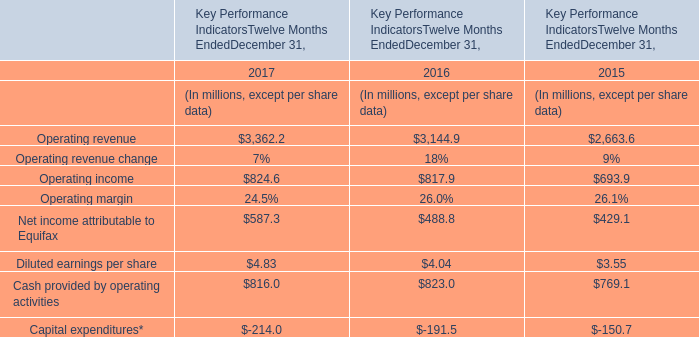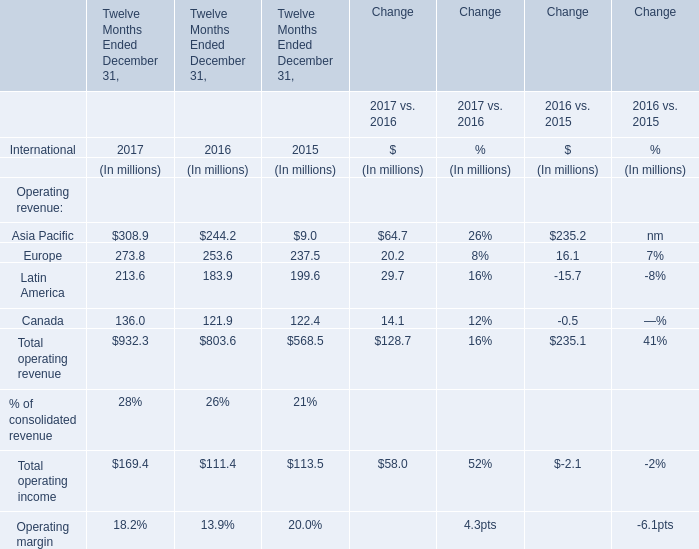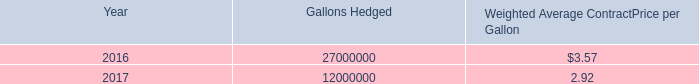What is the average increasing rate of consolidated revenue between 2016 and 2017? (in %) 
Computations: ((28 + 26) / 2)
Answer: 27.0. 